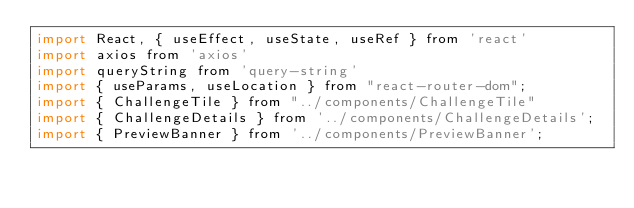<code> <loc_0><loc_0><loc_500><loc_500><_JavaScript_>import React, { useEffect, useState, useRef } from 'react'
import axios from 'axios'
import queryString from 'query-string'
import { useParams, useLocation } from "react-router-dom";
import { ChallengeTile } from "../components/ChallengeTile"
import { ChallengeDetails } from '../components/ChallengeDetails';
import { PreviewBanner } from '../components/PreviewBanner';
</code> 